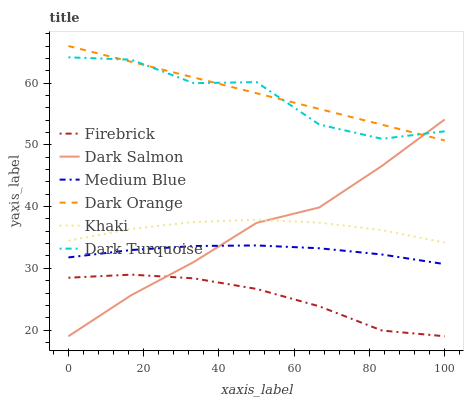Does Khaki have the minimum area under the curve?
Answer yes or no. No. Does Khaki have the maximum area under the curve?
Answer yes or no. No. Is Khaki the smoothest?
Answer yes or no. No. Is Khaki the roughest?
Answer yes or no. No. Does Khaki have the lowest value?
Answer yes or no. No. Does Khaki have the highest value?
Answer yes or no. No. Is Khaki less than Dark Turquoise?
Answer yes or no. Yes. Is Dark Turquoise greater than Medium Blue?
Answer yes or no. Yes. Does Khaki intersect Dark Turquoise?
Answer yes or no. No. 